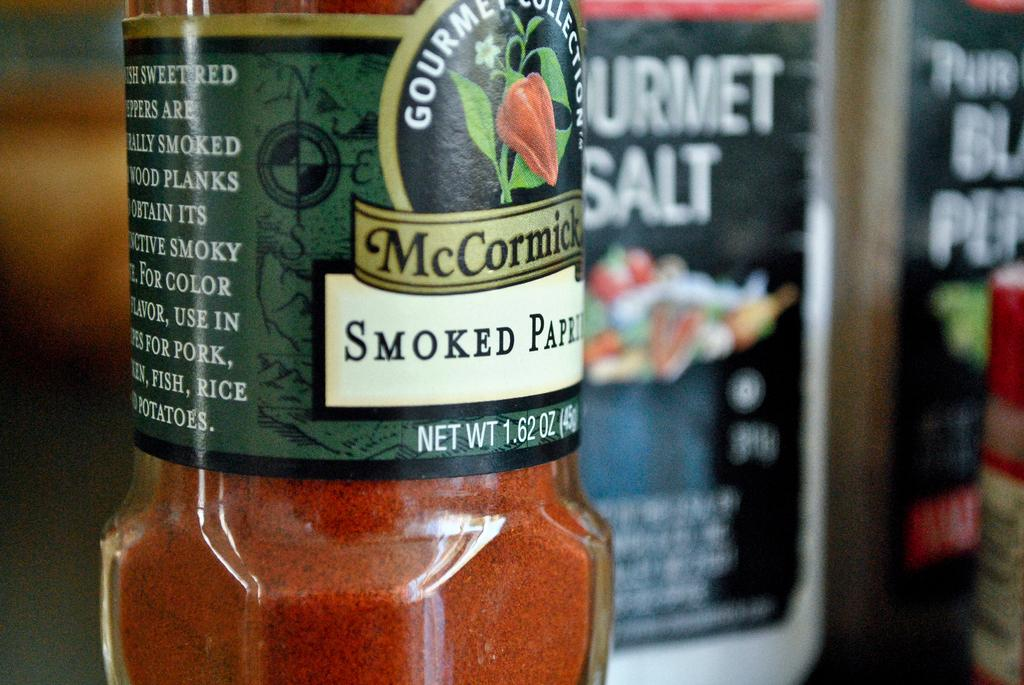Provide a one-sentence caption for the provided image. A jar of smoke paparika with a green label. 